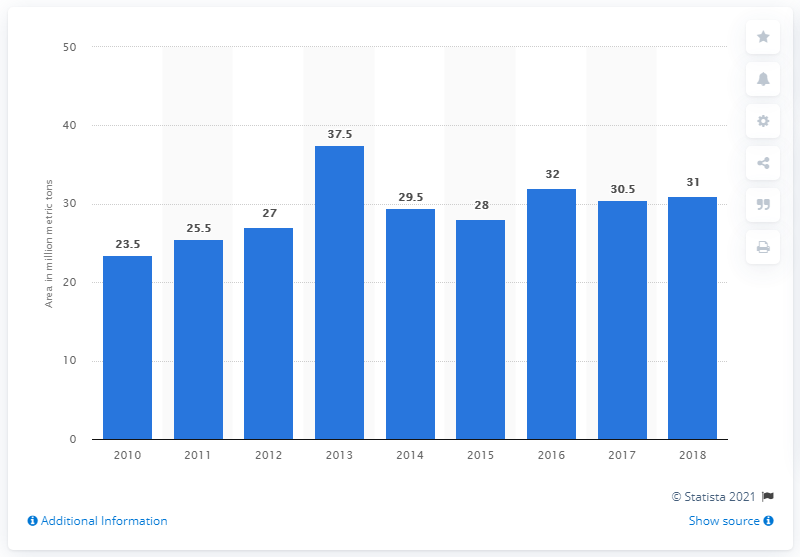List a handful of essential elements in this visual. In 2016, Canada produced approximately 32 million metric tons of wheat. In 2010, the last time wheat was produced in Canada. 